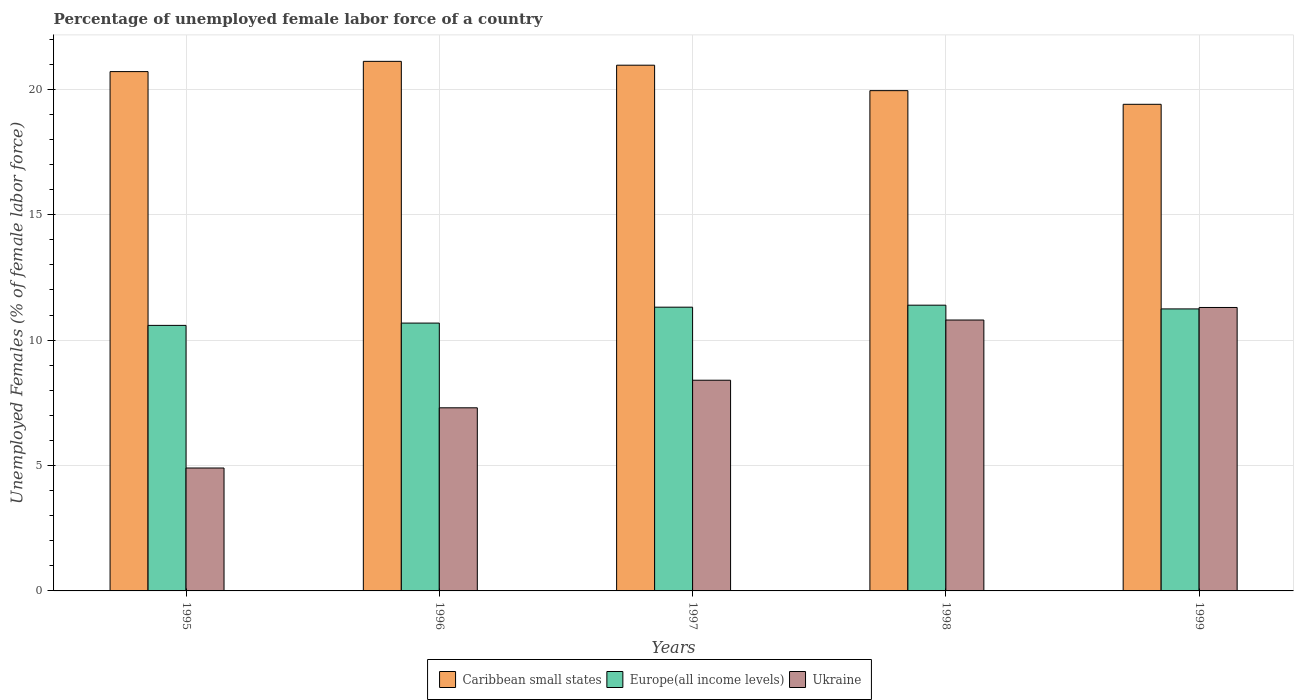How many groups of bars are there?
Ensure brevity in your answer.  5. How many bars are there on the 3rd tick from the left?
Make the answer very short. 3. What is the label of the 5th group of bars from the left?
Make the answer very short. 1999. What is the percentage of unemployed female labor force in Ukraine in 1998?
Keep it short and to the point. 10.8. Across all years, what is the maximum percentage of unemployed female labor force in Caribbean small states?
Make the answer very short. 21.11. Across all years, what is the minimum percentage of unemployed female labor force in Caribbean small states?
Provide a short and direct response. 19.4. In which year was the percentage of unemployed female labor force in Europe(all income levels) maximum?
Offer a terse response. 1998. What is the total percentage of unemployed female labor force in Caribbean small states in the graph?
Your answer should be very brief. 102.12. What is the difference between the percentage of unemployed female labor force in Caribbean small states in 1996 and that in 1998?
Your answer should be very brief. 1.17. What is the difference between the percentage of unemployed female labor force in Caribbean small states in 1996 and the percentage of unemployed female labor force in Ukraine in 1999?
Ensure brevity in your answer.  9.81. What is the average percentage of unemployed female labor force in Ukraine per year?
Provide a short and direct response. 8.54. In the year 1996, what is the difference between the percentage of unemployed female labor force in Europe(all income levels) and percentage of unemployed female labor force in Caribbean small states?
Provide a short and direct response. -10.43. What is the ratio of the percentage of unemployed female labor force in Ukraine in 1996 to that in 1997?
Ensure brevity in your answer.  0.87. What is the difference between the highest and the second highest percentage of unemployed female labor force in Caribbean small states?
Make the answer very short. 0.15. What is the difference between the highest and the lowest percentage of unemployed female labor force in Ukraine?
Offer a terse response. 6.4. In how many years, is the percentage of unemployed female labor force in Ukraine greater than the average percentage of unemployed female labor force in Ukraine taken over all years?
Your answer should be very brief. 2. Is the sum of the percentage of unemployed female labor force in Europe(all income levels) in 1995 and 1998 greater than the maximum percentage of unemployed female labor force in Caribbean small states across all years?
Your answer should be very brief. Yes. What does the 1st bar from the left in 1995 represents?
Provide a short and direct response. Caribbean small states. What does the 1st bar from the right in 1996 represents?
Provide a short and direct response. Ukraine. What is the difference between two consecutive major ticks on the Y-axis?
Offer a terse response. 5. Are the values on the major ticks of Y-axis written in scientific E-notation?
Offer a very short reply. No. Does the graph contain any zero values?
Your response must be concise. No. Where does the legend appear in the graph?
Provide a short and direct response. Bottom center. What is the title of the graph?
Keep it short and to the point. Percentage of unemployed female labor force of a country. What is the label or title of the X-axis?
Provide a succinct answer. Years. What is the label or title of the Y-axis?
Offer a terse response. Unemployed Females (% of female labor force). What is the Unemployed Females (% of female labor force) in Caribbean small states in 1995?
Make the answer very short. 20.7. What is the Unemployed Females (% of female labor force) of Europe(all income levels) in 1995?
Your answer should be very brief. 10.59. What is the Unemployed Females (% of female labor force) of Ukraine in 1995?
Offer a terse response. 4.9. What is the Unemployed Females (% of female labor force) in Caribbean small states in 1996?
Ensure brevity in your answer.  21.11. What is the Unemployed Females (% of female labor force) of Europe(all income levels) in 1996?
Your answer should be very brief. 10.68. What is the Unemployed Females (% of female labor force) of Ukraine in 1996?
Ensure brevity in your answer.  7.3. What is the Unemployed Females (% of female labor force) of Caribbean small states in 1997?
Your answer should be very brief. 20.96. What is the Unemployed Females (% of female labor force) of Europe(all income levels) in 1997?
Give a very brief answer. 11.31. What is the Unemployed Females (% of female labor force) in Ukraine in 1997?
Your answer should be compact. 8.4. What is the Unemployed Females (% of female labor force) of Caribbean small states in 1998?
Provide a short and direct response. 19.94. What is the Unemployed Females (% of female labor force) in Europe(all income levels) in 1998?
Your response must be concise. 11.39. What is the Unemployed Females (% of female labor force) in Ukraine in 1998?
Give a very brief answer. 10.8. What is the Unemployed Females (% of female labor force) of Caribbean small states in 1999?
Provide a succinct answer. 19.4. What is the Unemployed Females (% of female labor force) in Europe(all income levels) in 1999?
Ensure brevity in your answer.  11.24. What is the Unemployed Females (% of female labor force) in Ukraine in 1999?
Keep it short and to the point. 11.3. Across all years, what is the maximum Unemployed Females (% of female labor force) of Caribbean small states?
Give a very brief answer. 21.11. Across all years, what is the maximum Unemployed Females (% of female labor force) of Europe(all income levels)?
Keep it short and to the point. 11.39. Across all years, what is the maximum Unemployed Females (% of female labor force) of Ukraine?
Provide a short and direct response. 11.3. Across all years, what is the minimum Unemployed Females (% of female labor force) of Caribbean small states?
Offer a very short reply. 19.4. Across all years, what is the minimum Unemployed Females (% of female labor force) in Europe(all income levels)?
Provide a succinct answer. 10.59. Across all years, what is the minimum Unemployed Females (% of female labor force) in Ukraine?
Provide a short and direct response. 4.9. What is the total Unemployed Females (% of female labor force) in Caribbean small states in the graph?
Provide a short and direct response. 102.12. What is the total Unemployed Females (% of female labor force) in Europe(all income levels) in the graph?
Your response must be concise. 55.21. What is the total Unemployed Females (% of female labor force) of Ukraine in the graph?
Offer a very short reply. 42.7. What is the difference between the Unemployed Females (% of female labor force) in Caribbean small states in 1995 and that in 1996?
Make the answer very short. -0.41. What is the difference between the Unemployed Females (% of female labor force) of Europe(all income levels) in 1995 and that in 1996?
Provide a succinct answer. -0.09. What is the difference between the Unemployed Females (% of female labor force) of Caribbean small states in 1995 and that in 1997?
Your answer should be very brief. -0.26. What is the difference between the Unemployed Females (% of female labor force) of Europe(all income levels) in 1995 and that in 1997?
Give a very brief answer. -0.73. What is the difference between the Unemployed Females (% of female labor force) of Caribbean small states in 1995 and that in 1998?
Offer a terse response. 0.76. What is the difference between the Unemployed Females (% of female labor force) in Europe(all income levels) in 1995 and that in 1998?
Give a very brief answer. -0.81. What is the difference between the Unemployed Females (% of female labor force) in Ukraine in 1995 and that in 1998?
Offer a terse response. -5.9. What is the difference between the Unemployed Females (% of female labor force) of Caribbean small states in 1995 and that in 1999?
Your answer should be very brief. 1.3. What is the difference between the Unemployed Females (% of female labor force) in Europe(all income levels) in 1995 and that in 1999?
Your answer should be very brief. -0.66. What is the difference between the Unemployed Females (% of female labor force) of Ukraine in 1995 and that in 1999?
Your answer should be very brief. -6.4. What is the difference between the Unemployed Females (% of female labor force) in Caribbean small states in 1996 and that in 1997?
Make the answer very short. 0.15. What is the difference between the Unemployed Females (% of female labor force) in Europe(all income levels) in 1996 and that in 1997?
Ensure brevity in your answer.  -0.63. What is the difference between the Unemployed Females (% of female labor force) in Ukraine in 1996 and that in 1997?
Your answer should be compact. -1.1. What is the difference between the Unemployed Females (% of female labor force) in Caribbean small states in 1996 and that in 1998?
Offer a very short reply. 1.17. What is the difference between the Unemployed Females (% of female labor force) in Europe(all income levels) in 1996 and that in 1998?
Offer a very short reply. -0.71. What is the difference between the Unemployed Females (% of female labor force) of Ukraine in 1996 and that in 1998?
Your response must be concise. -3.5. What is the difference between the Unemployed Females (% of female labor force) of Caribbean small states in 1996 and that in 1999?
Ensure brevity in your answer.  1.71. What is the difference between the Unemployed Females (% of female labor force) of Europe(all income levels) in 1996 and that in 1999?
Offer a very short reply. -0.57. What is the difference between the Unemployed Females (% of female labor force) in Ukraine in 1996 and that in 1999?
Provide a succinct answer. -4. What is the difference between the Unemployed Females (% of female labor force) in Caribbean small states in 1997 and that in 1998?
Keep it short and to the point. 1.01. What is the difference between the Unemployed Females (% of female labor force) of Europe(all income levels) in 1997 and that in 1998?
Give a very brief answer. -0.08. What is the difference between the Unemployed Females (% of female labor force) in Caribbean small states in 1997 and that in 1999?
Give a very brief answer. 1.56. What is the difference between the Unemployed Females (% of female labor force) of Europe(all income levels) in 1997 and that in 1999?
Offer a terse response. 0.07. What is the difference between the Unemployed Females (% of female labor force) of Ukraine in 1997 and that in 1999?
Keep it short and to the point. -2.9. What is the difference between the Unemployed Females (% of female labor force) of Caribbean small states in 1998 and that in 1999?
Your answer should be very brief. 0.54. What is the difference between the Unemployed Females (% of female labor force) of Europe(all income levels) in 1998 and that in 1999?
Give a very brief answer. 0.15. What is the difference between the Unemployed Females (% of female labor force) of Caribbean small states in 1995 and the Unemployed Females (% of female labor force) of Europe(all income levels) in 1996?
Your answer should be compact. 10.03. What is the difference between the Unemployed Females (% of female labor force) of Caribbean small states in 1995 and the Unemployed Females (% of female labor force) of Ukraine in 1996?
Provide a succinct answer. 13.4. What is the difference between the Unemployed Females (% of female labor force) of Europe(all income levels) in 1995 and the Unemployed Females (% of female labor force) of Ukraine in 1996?
Your response must be concise. 3.29. What is the difference between the Unemployed Females (% of female labor force) in Caribbean small states in 1995 and the Unemployed Females (% of female labor force) in Europe(all income levels) in 1997?
Offer a terse response. 9.39. What is the difference between the Unemployed Females (% of female labor force) in Caribbean small states in 1995 and the Unemployed Females (% of female labor force) in Ukraine in 1997?
Keep it short and to the point. 12.3. What is the difference between the Unemployed Females (% of female labor force) of Europe(all income levels) in 1995 and the Unemployed Females (% of female labor force) of Ukraine in 1997?
Offer a terse response. 2.19. What is the difference between the Unemployed Females (% of female labor force) in Caribbean small states in 1995 and the Unemployed Females (% of female labor force) in Europe(all income levels) in 1998?
Make the answer very short. 9.31. What is the difference between the Unemployed Females (% of female labor force) in Caribbean small states in 1995 and the Unemployed Females (% of female labor force) in Ukraine in 1998?
Offer a terse response. 9.9. What is the difference between the Unemployed Females (% of female labor force) in Europe(all income levels) in 1995 and the Unemployed Females (% of female labor force) in Ukraine in 1998?
Your answer should be very brief. -0.21. What is the difference between the Unemployed Females (% of female labor force) in Caribbean small states in 1995 and the Unemployed Females (% of female labor force) in Europe(all income levels) in 1999?
Keep it short and to the point. 9.46. What is the difference between the Unemployed Females (% of female labor force) in Caribbean small states in 1995 and the Unemployed Females (% of female labor force) in Ukraine in 1999?
Provide a short and direct response. 9.4. What is the difference between the Unemployed Females (% of female labor force) in Europe(all income levels) in 1995 and the Unemployed Females (% of female labor force) in Ukraine in 1999?
Keep it short and to the point. -0.71. What is the difference between the Unemployed Females (% of female labor force) of Caribbean small states in 1996 and the Unemployed Females (% of female labor force) of Europe(all income levels) in 1997?
Provide a short and direct response. 9.8. What is the difference between the Unemployed Females (% of female labor force) in Caribbean small states in 1996 and the Unemployed Females (% of female labor force) in Ukraine in 1997?
Provide a succinct answer. 12.71. What is the difference between the Unemployed Females (% of female labor force) in Europe(all income levels) in 1996 and the Unemployed Females (% of female labor force) in Ukraine in 1997?
Make the answer very short. 2.28. What is the difference between the Unemployed Females (% of female labor force) in Caribbean small states in 1996 and the Unemployed Females (% of female labor force) in Europe(all income levels) in 1998?
Provide a succinct answer. 9.72. What is the difference between the Unemployed Females (% of female labor force) in Caribbean small states in 1996 and the Unemployed Females (% of female labor force) in Ukraine in 1998?
Offer a terse response. 10.31. What is the difference between the Unemployed Females (% of female labor force) of Europe(all income levels) in 1996 and the Unemployed Females (% of female labor force) of Ukraine in 1998?
Make the answer very short. -0.12. What is the difference between the Unemployed Females (% of female labor force) in Caribbean small states in 1996 and the Unemployed Females (% of female labor force) in Europe(all income levels) in 1999?
Ensure brevity in your answer.  9.87. What is the difference between the Unemployed Females (% of female labor force) of Caribbean small states in 1996 and the Unemployed Females (% of female labor force) of Ukraine in 1999?
Keep it short and to the point. 9.81. What is the difference between the Unemployed Females (% of female labor force) in Europe(all income levels) in 1996 and the Unemployed Females (% of female labor force) in Ukraine in 1999?
Provide a succinct answer. -0.62. What is the difference between the Unemployed Females (% of female labor force) in Caribbean small states in 1997 and the Unemployed Females (% of female labor force) in Europe(all income levels) in 1998?
Ensure brevity in your answer.  9.57. What is the difference between the Unemployed Females (% of female labor force) of Caribbean small states in 1997 and the Unemployed Females (% of female labor force) of Ukraine in 1998?
Your response must be concise. 10.16. What is the difference between the Unemployed Females (% of female labor force) of Europe(all income levels) in 1997 and the Unemployed Females (% of female labor force) of Ukraine in 1998?
Make the answer very short. 0.51. What is the difference between the Unemployed Females (% of female labor force) in Caribbean small states in 1997 and the Unemployed Females (% of female labor force) in Europe(all income levels) in 1999?
Your answer should be very brief. 9.72. What is the difference between the Unemployed Females (% of female labor force) in Caribbean small states in 1997 and the Unemployed Females (% of female labor force) in Ukraine in 1999?
Your answer should be compact. 9.66. What is the difference between the Unemployed Females (% of female labor force) in Europe(all income levels) in 1997 and the Unemployed Females (% of female labor force) in Ukraine in 1999?
Ensure brevity in your answer.  0.01. What is the difference between the Unemployed Females (% of female labor force) in Caribbean small states in 1998 and the Unemployed Females (% of female labor force) in Europe(all income levels) in 1999?
Provide a short and direct response. 8.7. What is the difference between the Unemployed Females (% of female labor force) of Caribbean small states in 1998 and the Unemployed Females (% of female labor force) of Ukraine in 1999?
Your answer should be very brief. 8.64. What is the difference between the Unemployed Females (% of female labor force) of Europe(all income levels) in 1998 and the Unemployed Females (% of female labor force) of Ukraine in 1999?
Give a very brief answer. 0.09. What is the average Unemployed Females (% of female labor force) of Caribbean small states per year?
Your answer should be compact. 20.42. What is the average Unemployed Females (% of female labor force) in Europe(all income levels) per year?
Ensure brevity in your answer.  11.04. What is the average Unemployed Females (% of female labor force) of Ukraine per year?
Provide a short and direct response. 8.54. In the year 1995, what is the difference between the Unemployed Females (% of female labor force) of Caribbean small states and Unemployed Females (% of female labor force) of Europe(all income levels)?
Provide a short and direct response. 10.12. In the year 1995, what is the difference between the Unemployed Females (% of female labor force) of Caribbean small states and Unemployed Females (% of female labor force) of Ukraine?
Provide a succinct answer. 15.8. In the year 1995, what is the difference between the Unemployed Females (% of female labor force) of Europe(all income levels) and Unemployed Females (% of female labor force) of Ukraine?
Provide a short and direct response. 5.69. In the year 1996, what is the difference between the Unemployed Females (% of female labor force) in Caribbean small states and Unemployed Females (% of female labor force) in Europe(all income levels)?
Offer a terse response. 10.43. In the year 1996, what is the difference between the Unemployed Females (% of female labor force) of Caribbean small states and Unemployed Females (% of female labor force) of Ukraine?
Offer a very short reply. 13.81. In the year 1996, what is the difference between the Unemployed Females (% of female labor force) in Europe(all income levels) and Unemployed Females (% of female labor force) in Ukraine?
Provide a short and direct response. 3.38. In the year 1997, what is the difference between the Unemployed Females (% of female labor force) of Caribbean small states and Unemployed Females (% of female labor force) of Europe(all income levels)?
Give a very brief answer. 9.65. In the year 1997, what is the difference between the Unemployed Females (% of female labor force) in Caribbean small states and Unemployed Females (% of female labor force) in Ukraine?
Keep it short and to the point. 12.56. In the year 1997, what is the difference between the Unemployed Females (% of female labor force) of Europe(all income levels) and Unemployed Females (% of female labor force) of Ukraine?
Ensure brevity in your answer.  2.91. In the year 1998, what is the difference between the Unemployed Females (% of female labor force) in Caribbean small states and Unemployed Females (% of female labor force) in Europe(all income levels)?
Make the answer very short. 8.55. In the year 1998, what is the difference between the Unemployed Females (% of female labor force) in Caribbean small states and Unemployed Females (% of female labor force) in Ukraine?
Make the answer very short. 9.14. In the year 1998, what is the difference between the Unemployed Females (% of female labor force) in Europe(all income levels) and Unemployed Females (% of female labor force) in Ukraine?
Provide a succinct answer. 0.59. In the year 1999, what is the difference between the Unemployed Females (% of female labor force) of Caribbean small states and Unemployed Females (% of female labor force) of Europe(all income levels)?
Give a very brief answer. 8.16. In the year 1999, what is the difference between the Unemployed Females (% of female labor force) in Caribbean small states and Unemployed Females (% of female labor force) in Ukraine?
Keep it short and to the point. 8.1. In the year 1999, what is the difference between the Unemployed Females (% of female labor force) of Europe(all income levels) and Unemployed Females (% of female labor force) of Ukraine?
Offer a terse response. -0.06. What is the ratio of the Unemployed Females (% of female labor force) of Caribbean small states in 1995 to that in 1996?
Give a very brief answer. 0.98. What is the ratio of the Unemployed Females (% of female labor force) of Europe(all income levels) in 1995 to that in 1996?
Offer a very short reply. 0.99. What is the ratio of the Unemployed Females (% of female labor force) of Ukraine in 1995 to that in 1996?
Make the answer very short. 0.67. What is the ratio of the Unemployed Females (% of female labor force) in Caribbean small states in 1995 to that in 1997?
Provide a succinct answer. 0.99. What is the ratio of the Unemployed Females (% of female labor force) in Europe(all income levels) in 1995 to that in 1997?
Make the answer very short. 0.94. What is the ratio of the Unemployed Females (% of female labor force) of Ukraine in 1995 to that in 1997?
Ensure brevity in your answer.  0.58. What is the ratio of the Unemployed Females (% of female labor force) in Caribbean small states in 1995 to that in 1998?
Offer a terse response. 1.04. What is the ratio of the Unemployed Females (% of female labor force) in Europe(all income levels) in 1995 to that in 1998?
Offer a very short reply. 0.93. What is the ratio of the Unemployed Females (% of female labor force) of Ukraine in 1995 to that in 1998?
Provide a succinct answer. 0.45. What is the ratio of the Unemployed Females (% of female labor force) in Caribbean small states in 1995 to that in 1999?
Provide a short and direct response. 1.07. What is the ratio of the Unemployed Females (% of female labor force) in Europe(all income levels) in 1995 to that in 1999?
Your response must be concise. 0.94. What is the ratio of the Unemployed Females (% of female labor force) of Ukraine in 1995 to that in 1999?
Offer a terse response. 0.43. What is the ratio of the Unemployed Females (% of female labor force) of Caribbean small states in 1996 to that in 1997?
Your answer should be very brief. 1.01. What is the ratio of the Unemployed Females (% of female labor force) of Europe(all income levels) in 1996 to that in 1997?
Offer a terse response. 0.94. What is the ratio of the Unemployed Females (% of female labor force) of Ukraine in 1996 to that in 1997?
Ensure brevity in your answer.  0.87. What is the ratio of the Unemployed Females (% of female labor force) of Caribbean small states in 1996 to that in 1998?
Give a very brief answer. 1.06. What is the ratio of the Unemployed Females (% of female labor force) of Europe(all income levels) in 1996 to that in 1998?
Your response must be concise. 0.94. What is the ratio of the Unemployed Females (% of female labor force) of Ukraine in 1996 to that in 1998?
Provide a succinct answer. 0.68. What is the ratio of the Unemployed Females (% of female labor force) in Caribbean small states in 1996 to that in 1999?
Your answer should be compact. 1.09. What is the ratio of the Unemployed Females (% of female labor force) of Europe(all income levels) in 1996 to that in 1999?
Give a very brief answer. 0.95. What is the ratio of the Unemployed Females (% of female labor force) in Ukraine in 1996 to that in 1999?
Ensure brevity in your answer.  0.65. What is the ratio of the Unemployed Females (% of female labor force) in Caribbean small states in 1997 to that in 1998?
Keep it short and to the point. 1.05. What is the ratio of the Unemployed Females (% of female labor force) of Europe(all income levels) in 1997 to that in 1998?
Offer a terse response. 0.99. What is the ratio of the Unemployed Females (% of female labor force) in Ukraine in 1997 to that in 1998?
Keep it short and to the point. 0.78. What is the ratio of the Unemployed Females (% of female labor force) of Caribbean small states in 1997 to that in 1999?
Give a very brief answer. 1.08. What is the ratio of the Unemployed Females (% of female labor force) of Ukraine in 1997 to that in 1999?
Offer a very short reply. 0.74. What is the ratio of the Unemployed Females (% of female labor force) of Caribbean small states in 1998 to that in 1999?
Offer a terse response. 1.03. What is the ratio of the Unemployed Females (% of female labor force) of Europe(all income levels) in 1998 to that in 1999?
Your answer should be compact. 1.01. What is the ratio of the Unemployed Females (% of female labor force) in Ukraine in 1998 to that in 1999?
Your response must be concise. 0.96. What is the difference between the highest and the second highest Unemployed Females (% of female labor force) of Caribbean small states?
Give a very brief answer. 0.15. What is the difference between the highest and the second highest Unemployed Females (% of female labor force) of Europe(all income levels)?
Give a very brief answer. 0.08. What is the difference between the highest and the second highest Unemployed Females (% of female labor force) of Ukraine?
Offer a terse response. 0.5. What is the difference between the highest and the lowest Unemployed Females (% of female labor force) of Caribbean small states?
Your answer should be compact. 1.71. What is the difference between the highest and the lowest Unemployed Females (% of female labor force) in Europe(all income levels)?
Ensure brevity in your answer.  0.81. What is the difference between the highest and the lowest Unemployed Females (% of female labor force) of Ukraine?
Give a very brief answer. 6.4. 